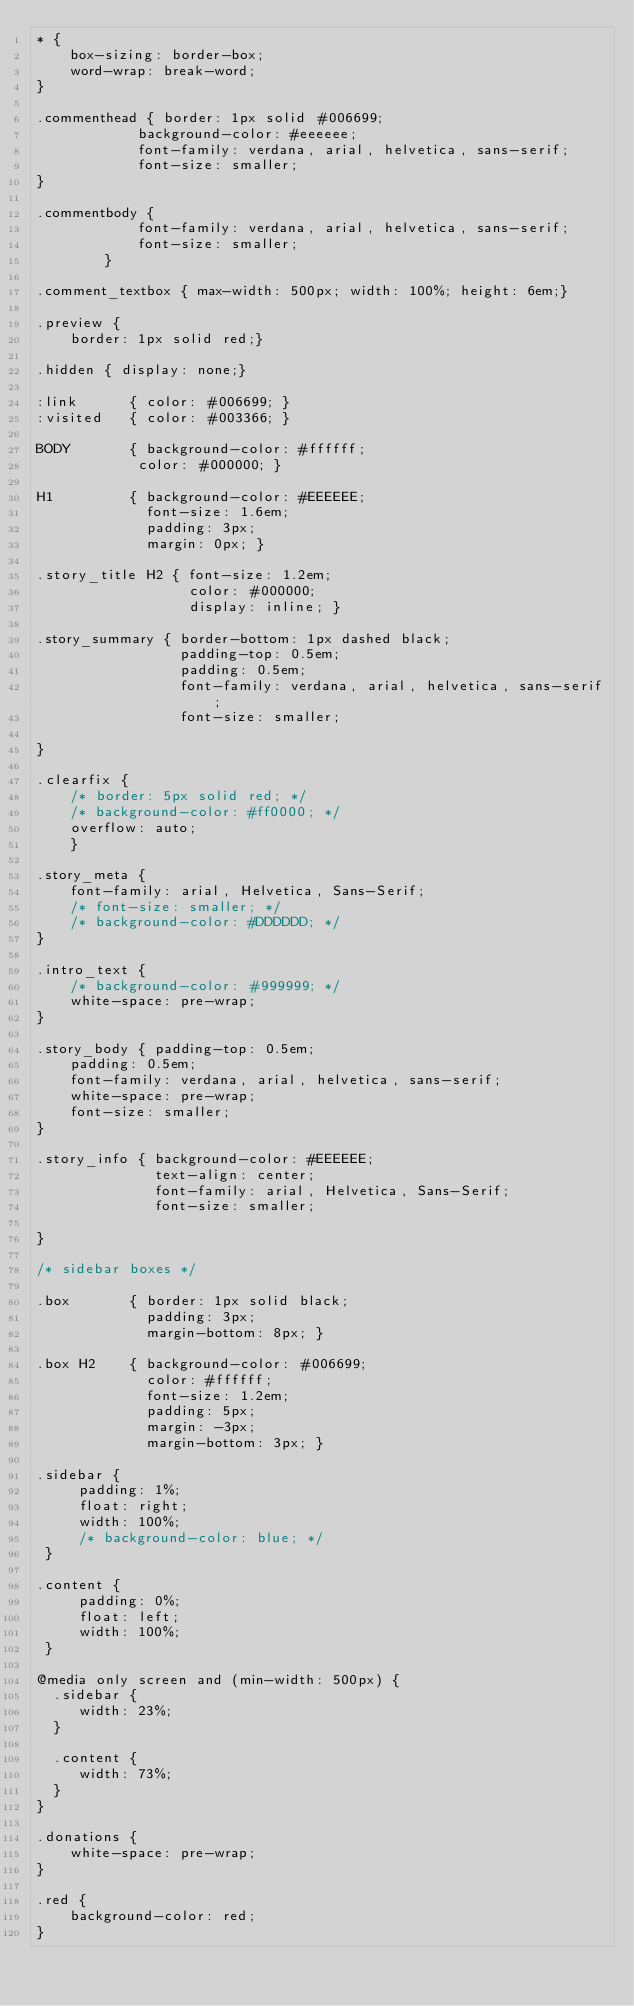<code> <loc_0><loc_0><loc_500><loc_500><_CSS_>* {
    box-sizing: border-box;
    word-wrap: break-word;
}

.commenthead { border: 1px solid #006699;
            background-color: #eeeeee;
            font-family: verdana, arial, helvetica, sans-serif;
            font-size: smaller;
}

.commentbody {
            font-family: verdana, arial, helvetica, sans-serif;
            font-size: smaller;
        }

.comment_textbox { max-width: 500px; width: 100%; height: 6em;}

.preview { 
    border: 1px solid red;}

.hidden { display: none;}
            
:link      { color: #006699; }
:visited   { color: #003366; }

BODY       { background-color: #ffffff;
            color: #000000; }

H1         { background-color: #EEEEEE;
             font-size: 1.6em;
             padding: 3px;
             margin: 0px; }
             
.story_title H2 { font-size: 1.2em;
                  color: #000000;
                  display: inline; }

.story_summary { border-bottom: 1px dashed black;
                 padding-top: 0.5em; 
                 padding: 0.5em;
                 font-family: verdana, arial, helvetica, sans-serif;
                 font-size: smaller;

}

.clearfix { 
    /* border: 5px solid red; */
    /* background-color: #ff0000; */
    overflow: auto;
    }
                 
.story_meta {
    font-family: arial, Helvetica, Sans-Serif;
    /* font-size: smaller; */
    /* background-color: #DDDDDD; */
}

.intro_text {
    /* background-color: #999999; */
    white-space: pre-wrap;
}

.story_body { padding-top: 0.5em; 
    padding: 0.5em;
    font-family: verdana, arial, helvetica, sans-serif;
    white-space: pre-wrap;
    font-size: smaller;
}

.story_info { background-color: #EEEEEE;
              text-align: center; 
              font-family: arial, Helvetica, Sans-Serif;
              font-size: smaller;
    
}

/* sidebar boxes */

.box       { border: 1px solid black;
             padding: 3px;
             margin-bottom: 8px; }

.box H2    { background-color: #006699;
             color: #ffffff;
             font-size: 1.2em;
             padding: 5px;
             margin: -3px;
             margin-bottom: 3px; }              
              
.sidebar {
     padding: 1%;
     float: right;
     width: 100%;
     /* background-color: blue; */
 }

.content {
     padding: 0%;
     float: left;
     width: 100%;     
 }
 
@media only screen and (min-width: 500px) {
  .sidebar {
     width: 23%;     
  }
   
  .content {
     width: 73%;     
  }
}

.donations {
    white-space: pre-wrap;
}

.red {
    background-color: red;
}</code> 